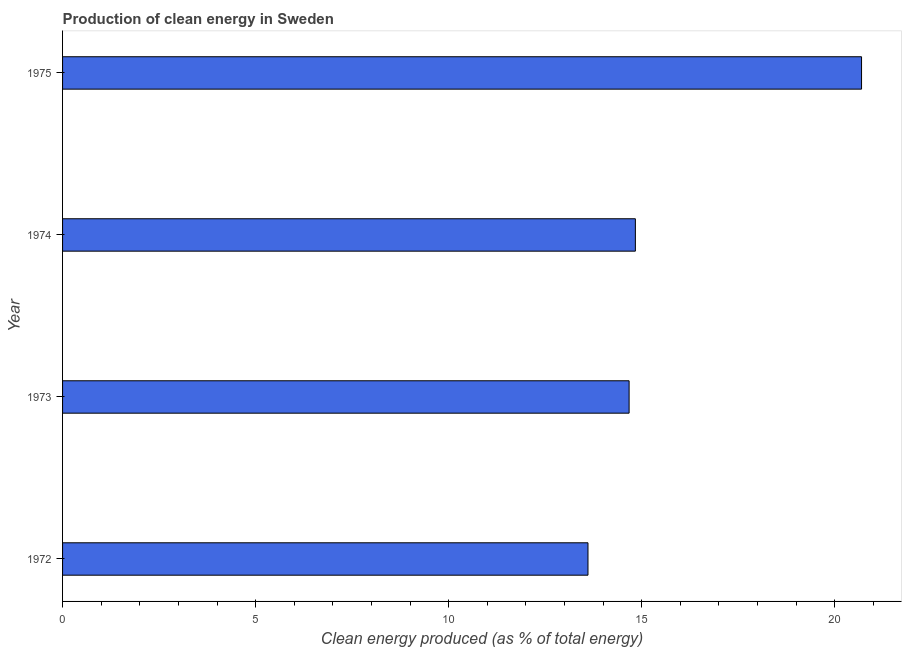Does the graph contain any zero values?
Keep it short and to the point. No. What is the title of the graph?
Give a very brief answer. Production of clean energy in Sweden. What is the label or title of the X-axis?
Provide a succinct answer. Clean energy produced (as % of total energy). What is the production of clean energy in 1975?
Make the answer very short. 20.69. Across all years, what is the maximum production of clean energy?
Give a very brief answer. 20.69. Across all years, what is the minimum production of clean energy?
Keep it short and to the point. 13.61. In which year was the production of clean energy maximum?
Give a very brief answer. 1975. In which year was the production of clean energy minimum?
Ensure brevity in your answer.  1972. What is the sum of the production of clean energy?
Offer a terse response. 63.81. What is the difference between the production of clean energy in 1973 and 1974?
Your answer should be very brief. -0.16. What is the average production of clean energy per year?
Make the answer very short. 15.95. What is the median production of clean energy?
Ensure brevity in your answer.  14.75. In how many years, is the production of clean energy greater than 6 %?
Keep it short and to the point. 4. Do a majority of the years between 1975 and 1974 (inclusive) have production of clean energy greater than 16 %?
Ensure brevity in your answer.  No. What is the ratio of the production of clean energy in 1972 to that in 1974?
Provide a short and direct response. 0.92. Is the production of clean energy in 1974 less than that in 1975?
Provide a short and direct response. Yes. Is the difference between the production of clean energy in 1972 and 1974 greater than the difference between any two years?
Keep it short and to the point. No. What is the difference between the highest and the second highest production of clean energy?
Offer a very short reply. 5.86. Is the sum of the production of clean energy in 1972 and 1974 greater than the maximum production of clean energy across all years?
Provide a short and direct response. Yes. What is the difference between the highest and the lowest production of clean energy?
Provide a short and direct response. 7.09. In how many years, is the production of clean energy greater than the average production of clean energy taken over all years?
Your answer should be compact. 1. Are all the bars in the graph horizontal?
Give a very brief answer. Yes. How many years are there in the graph?
Offer a very short reply. 4. What is the difference between two consecutive major ticks on the X-axis?
Provide a short and direct response. 5. Are the values on the major ticks of X-axis written in scientific E-notation?
Provide a succinct answer. No. What is the Clean energy produced (as % of total energy) of 1972?
Give a very brief answer. 13.61. What is the Clean energy produced (as % of total energy) in 1973?
Make the answer very short. 14.67. What is the Clean energy produced (as % of total energy) in 1974?
Your answer should be very brief. 14.84. What is the Clean energy produced (as % of total energy) in 1975?
Offer a terse response. 20.69. What is the difference between the Clean energy produced (as % of total energy) in 1972 and 1973?
Ensure brevity in your answer.  -1.07. What is the difference between the Clean energy produced (as % of total energy) in 1972 and 1974?
Provide a short and direct response. -1.23. What is the difference between the Clean energy produced (as % of total energy) in 1972 and 1975?
Provide a succinct answer. -7.09. What is the difference between the Clean energy produced (as % of total energy) in 1973 and 1974?
Offer a terse response. -0.16. What is the difference between the Clean energy produced (as % of total energy) in 1973 and 1975?
Give a very brief answer. -6.02. What is the difference between the Clean energy produced (as % of total energy) in 1974 and 1975?
Provide a succinct answer. -5.86. What is the ratio of the Clean energy produced (as % of total energy) in 1972 to that in 1973?
Offer a terse response. 0.93. What is the ratio of the Clean energy produced (as % of total energy) in 1972 to that in 1974?
Offer a very short reply. 0.92. What is the ratio of the Clean energy produced (as % of total energy) in 1972 to that in 1975?
Make the answer very short. 0.66. What is the ratio of the Clean energy produced (as % of total energy) in 1973 to that in 1975?
Ensure brevity in your answer.  0.71. What is the ratio of the Clean energy produced (as % of total energy) in 1974 to that in 1975?
Offer a very short reply. 0.72. 